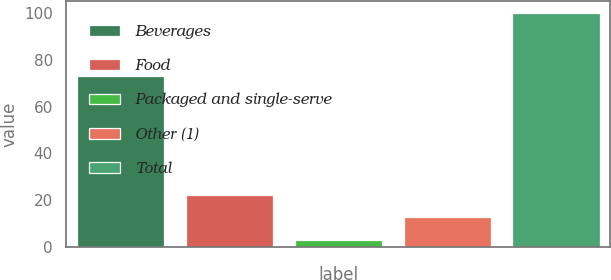Convert chart. <chart><loc_0><loc_0><loc_500><loc_500><bar_chart><fcel>Beverages<fcel>Food<fcel>Packaged and single-serve<fcel>Other (1)<fcel>Total<nl><fcel>73<fcel>22.4<fcel>3<fcel>12.7<fcel>100<nl></chart> 